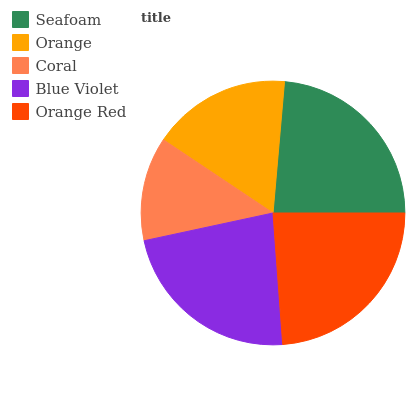Is Coral the minimum?
Answer yes or no. Yes. Is Orange Red the maximum?
Answer yes or no. Yes. Is Orange the minimum?
Answer yes or no. No. Is Orange the maximum?
Answer yes or no. No. Is Seafoam greater than Orange?
Answer yes or no. Yes. Is Orange less than Seafoam?
Answer yes or no. Yes. Is Orange greater than Seafoam?
Answer yes or no. No. Is Seafoam less than Orange?
Answer yes or no. No. Is Blue Violet the high median?
Answer yes or no. Yes. Is Blue Violet the low median?
Answer yes or no. Yes. Is Orange Red the high median?
Answer yes or no. No. Is Orange Red the low median?
Answer yes or no. No. 